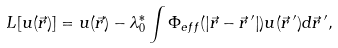<formula> <loc_0><loc_0><loc_500><loc_500>L [ u ( \vec { r } ) ] = u ( \vec { r } ) - \lambda _ { 0 } ^ { * } \int \Phi _ { e f f } ( \left | \vec { r } - \vec { r } \, ^ { \prime } \right | ) u ( \vec { r } \, ^ { \prime } ) d \vec { r } \, ^ { \prime } ,</formula> 